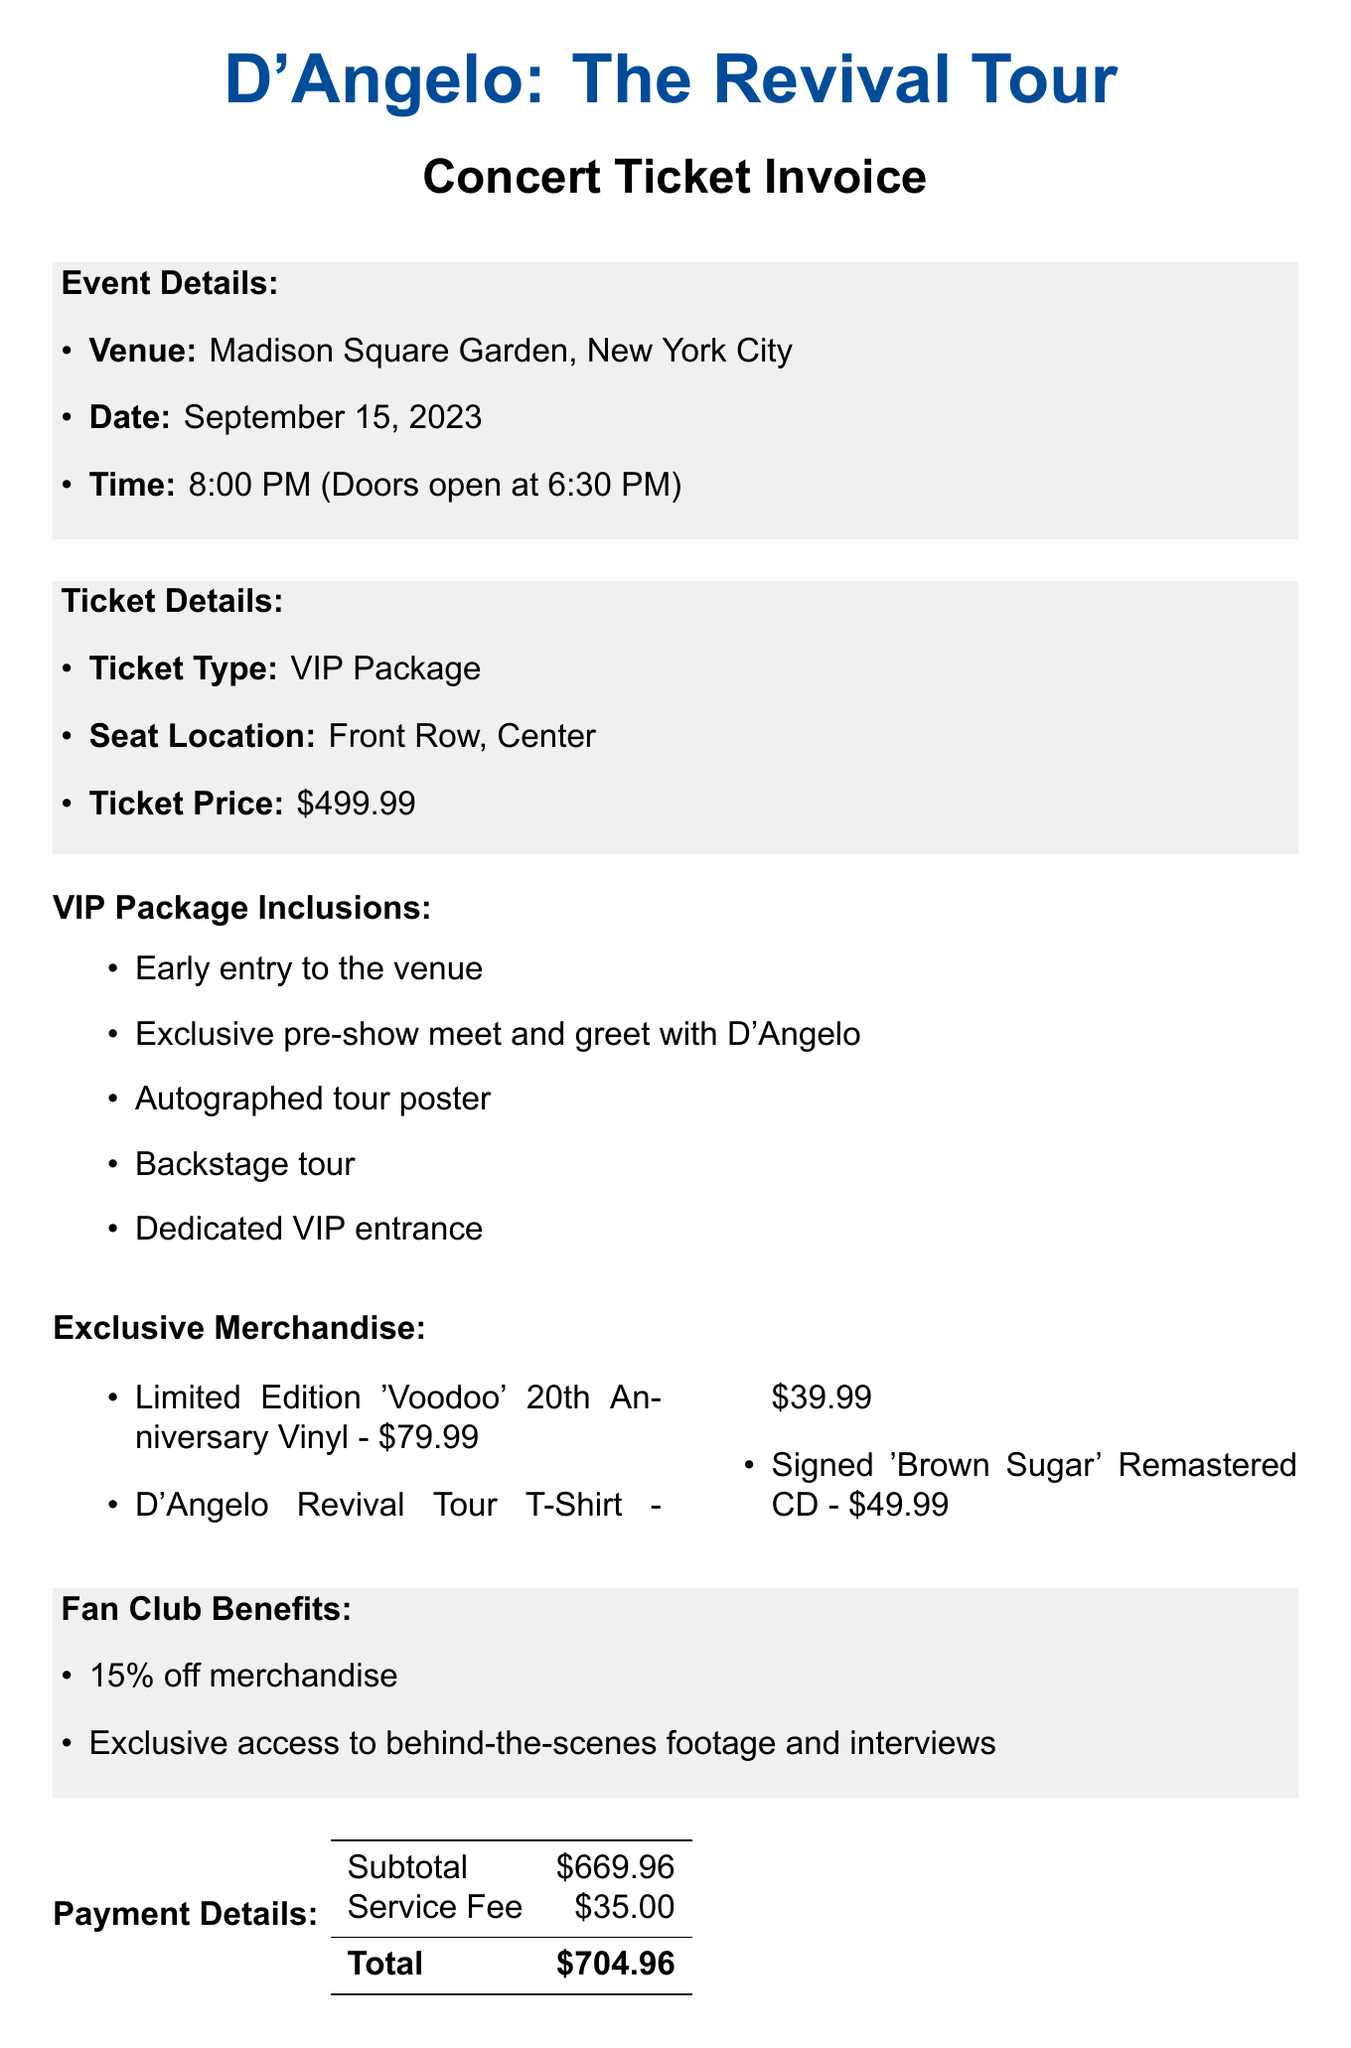What is the event name? The event name is explicitly stated at the top of the document under the title, which is "D'Angelo: The Revival Tour."
Answer: D'Angelo: The Revival Tour What is the date of the concert? The date of the concert is provided in the event details section, which is listed as September 15, 2023.
Answer: September 15, 2023 What is the price of the VIP package? The ticket price is mentioned within the ticket details section, for the VIP package it is $499.99.
Answer: $499.99 What item is included in the VIP package? The list of inclusions for the VIP package mentions several items, one of which is the "Exclusive pre-show meet and greet with D'Angelo."
Answer: Exclusive pre-show meet and greet with D'Angelo How much do the Limited Edition 'Voodoo' vinyl cost? The price for the Limited Edition 'Voodoo' 20th Anniversary Vinyl is specified in the merchandise section as $79.99.
Answer: $79.99 What is the total amount payable? The total amount payable is clearly detailed in the payment section as $704.96.
Answer: $704.96 What is the customer name listed on the invoice? The customer name is stated at the bottom of the document where it identifies the purchaser, which is "Devoted D'Angelo Fan."
Answer: Devoted D'Angelo Fan What time do the doors open? The time when the doors open is mentioned in the event details section, which is at 6:30 PM.
Answer: 6:30 PM How much discount do fan club members receive on merchandise? The fan club benefits section indicates that members receive a 15% discount on merchandise.
Answer: 15% 